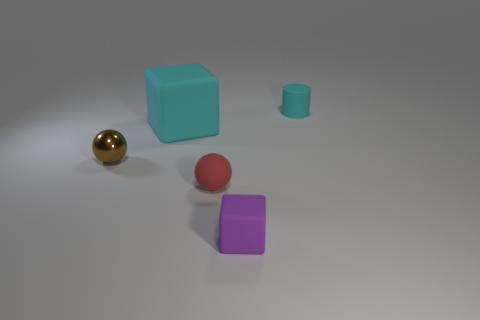There is a cyan thing that is the same size as the red rubber ball; what is its shape? The cyan object in question, while similar in size to the red rubber ball, is actually cube-shaped, featuring equal-length sides and sharp edges that contrast with the ball's spherical form. 